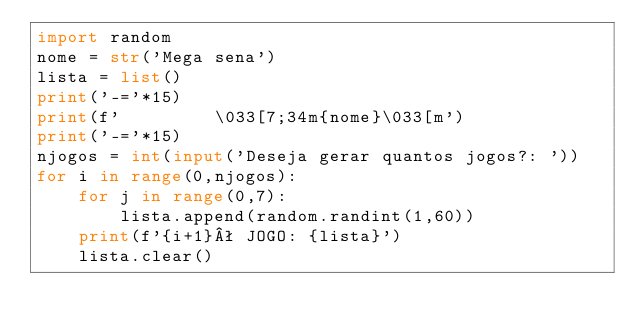Convert code to text. <code><loc_0><loc_0><loc_500><loc_500><_Python_>import random
nome = str('Mega sena')
lista = list()
print('-='*15)
print(f'         \033[7;34m{nome}\033[m')
print('-='*15)
njogos = int(input('Deseja gerar quantos jogos?: '))
for i in range(0,njogos):
    for j in range(0,7):
        lista.append(random.randint(1,60))
    print(f'{i+1}ª JOGO: {lista}')
    lista.clear()</code> 